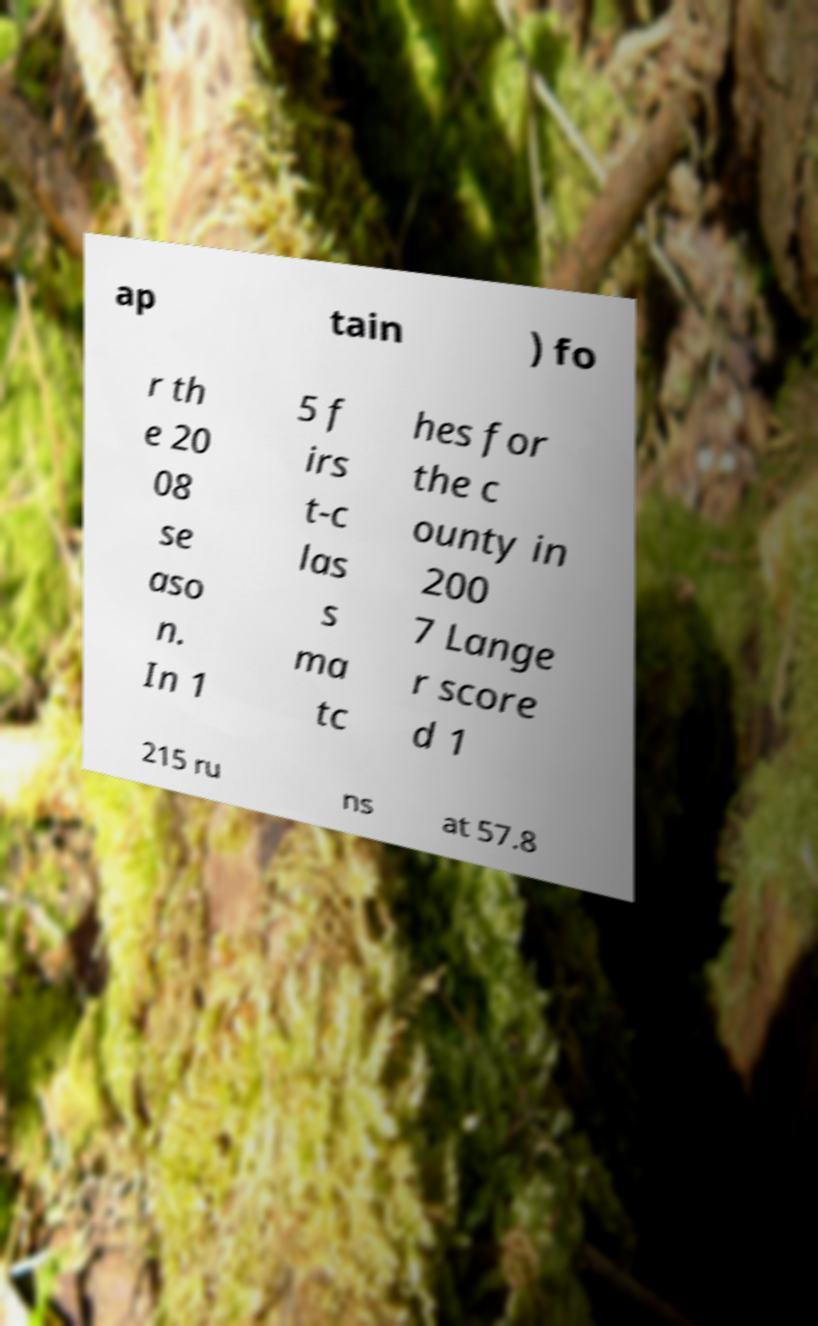Could you extract and type out the text from this image? ap tain ) fo r th e 20 08 se aso n. In 1 5 f irs t-c las s ma tc hes for the c ounty in 200 7 Lange r score d 1 215 ru ns at 57.8 